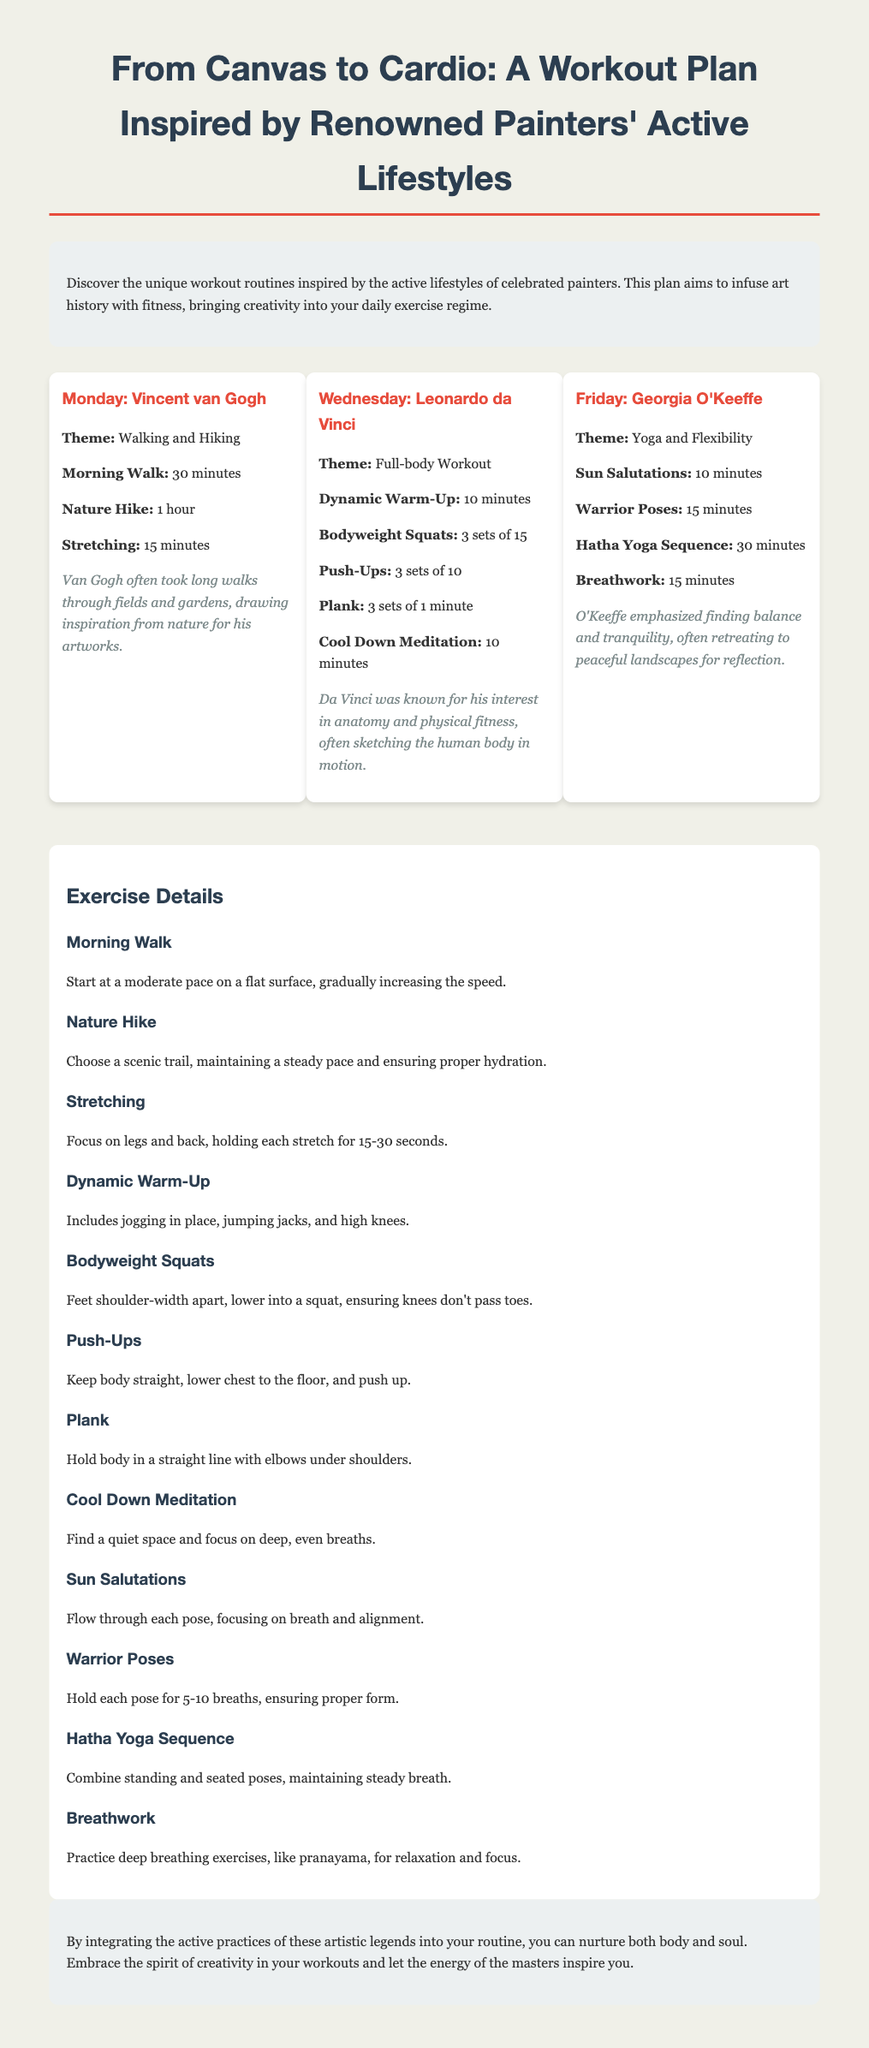What is the title of the workout plan? The title is prominently displayed at the top of the document.
Answer: From Canvas to Cardio: A Workout Plan Inspired by Renowned Painters' Active Lifestyles Which painter is associated with Monday's workout? The specific painter is mentioned in the heading for Monday's workout.
Answer: Vincent van Gogh How long is the 'Nature Hike' exercise? The duration for the exercise is detailed in the Monday routine.
Answer: 1 hour What type of exercise is emphasized on Friday? The theme for Friday specifically highlights a type of exercise.
Answer: Yoga and Flexibility How many sets are prescribed for Bodyweight Squats? The number of sets is included in the details of the Wednesday workout routine.
Answer: 3 sets What is featured in the introduction section? The introduction provides insight into the purpose of the workout plan.
Answer: Unique workout routines inspired by active lifestyles of celebrated painters How long should the Cool Down Meditation last? The duration is specified in the Wednesday exercise details.
Answer: 10 minutes What do the notes for Georgia O'Keeffe's workout emphasize? The notes provide additional context related to O'Keeffe's philosophy reflected in the workout.
Answer: Finding balance and tranquility 